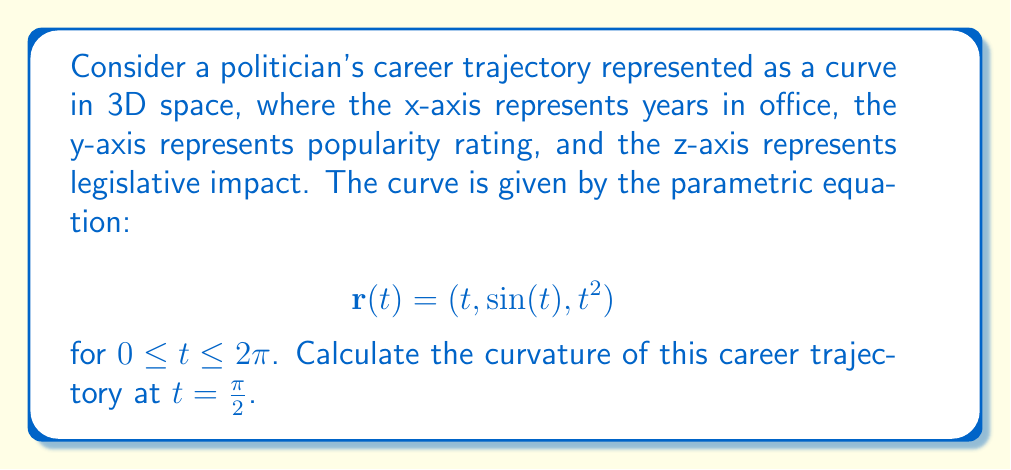What is the answer to this math problem? To calculate the curvature of a curve in 3D space, we use the formula:

$$\kappa = \frac{|\mathbf{r}'(t) \times \mathbf{r}''(t)|}{|\mathbf{r}'(t)|^3}$$

Step 1: Calculate $\mathbf{r}'(t)$
$$\mathbf{r}'(t) = (1, \cos(t), 2t)$$

Step 2: Calculate $\mathbf{r}''(t)$
$$\mathbf{r}''(t) = (0, -\sin(t), 2)$$

Step 3: Evaluate $\mathbf{r}'(t)$ and $\mathbf{r}''(t)$ at $t = \frac{\pi}{2}$
$$\mathbf{r}'(\frac{\pi}{2}) = (1, 0, \pi)$$
$$\mathbf{r}''(\frac{\pi}{2}) = (0, -1, 2)$$

Step 4: Calculate the cross product $\mathbf{r}'(\frac{\pi}{2}) \times \mathbf{r}''(\frac{\pi}{2})$
$$\mathbf{r}'(\frac{\pi}{2}) \times \mathbf{r}''(\frac{\pi}{2}) = (1, 0, \pi) \times (0, -1, 2) = (\pi, -2, 1)$$

Step 5: Calculate the magnitude of the cross product
$$|\mathbf{r}'(\frac{\pi}{2}) \times \mathbf{r}''(\frac{\pi}{2})| = \sqrt{\pi^2 + 4 + 1}$$

Step 6: Calculate $|\mathbf{r}'(\frac{\pi}{2})|^3$
$$|\mathbf{r}'(\frac{\pi}{2})|^3 = (1^2 + 0^2 + \pi^2)^{3/2} = (1 + \pi^2)^{3/2}$$

Step 7: Apply the curvature formula
$$\kappa = \frac{\sqrt{\pi^2 + 5}}{(1 + \pi^2)^{3/2}}$$
Answer: $\kappa = \frac{\sqrt{\pi^2 + 5}}{(1 + \pi^2)^{3/2}}$ 